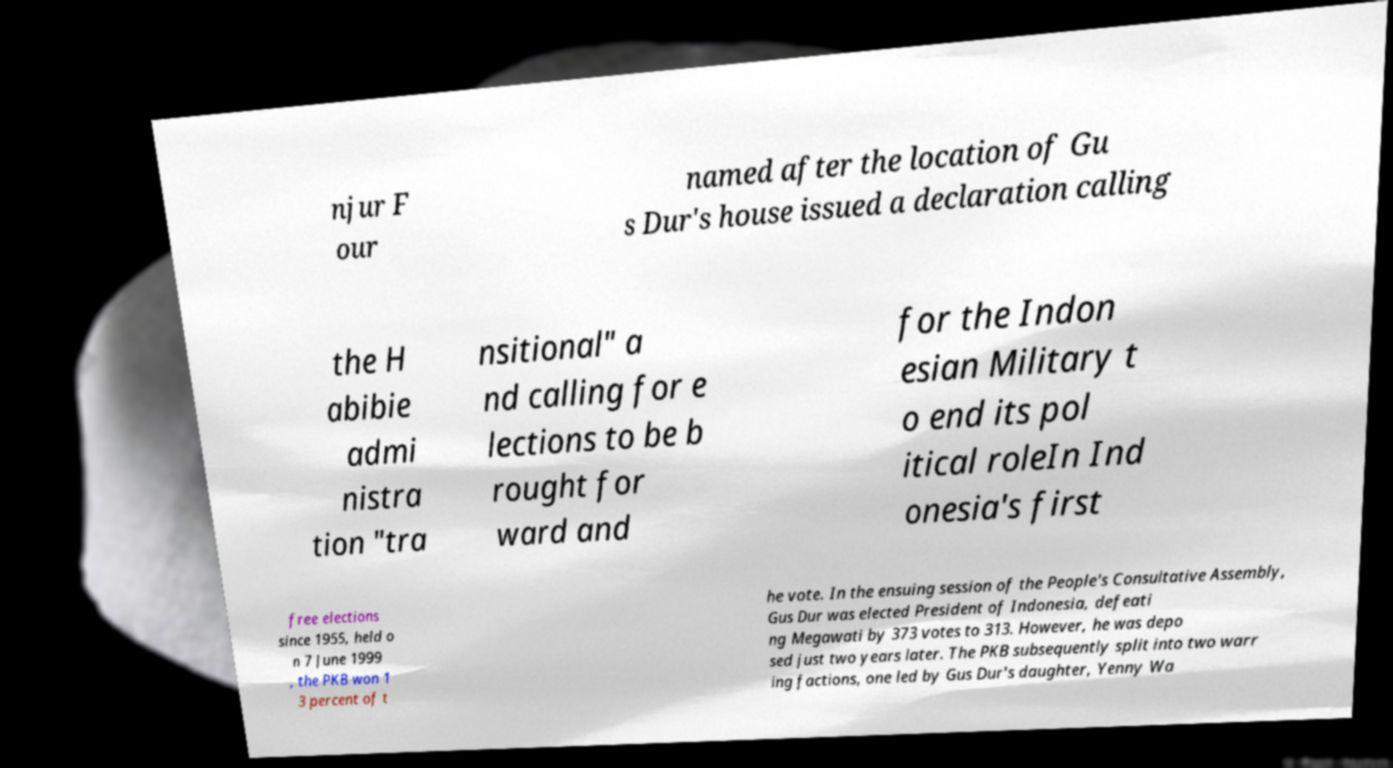What messages or text are displayed in this image? I need them in a readable, typed format. njur F our named after the location of Gu s Dur's house issued a declaration calling the H abibie admi nistra tion "tra nsitional" a nd calling for e lections to be b rought for ward and for the Indon esian Military t o end its pol itical roleIn Ind onesia's first free elections since 1955, held o n 7 June 1999 , the PKB won 1 3 percent of t he vote. In the ensuing session of the People's Consultative Assembly, Gus Dur was elected President of Indonesia, defeati ng Megawati by 373 votes to 313. However, he was depo sed just two years later. The PKB subsequently split into two warr ing factions, one led by Gus Dur's daughter, Yenny Wa 